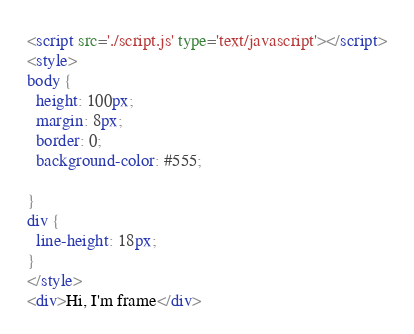<code> <loc_0><loc_0><loc_500><loc_500><_HTML_><script src='./script.js' type='text/javascript'></script>
<style>
body {
  height: 100px;
  margin: 8px;
  border: 0;
  background-color: #555;

}
div {
  line-height: 18px;
}
</style>
<div>Hi, I'm frame</div>
</code> 